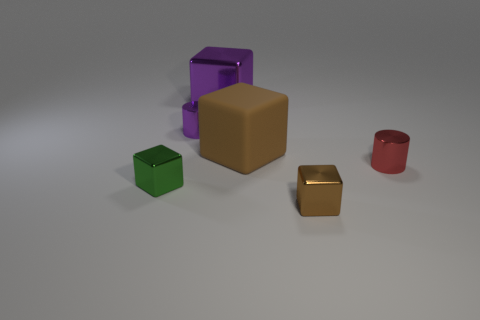Subtract all large brown blocks. How many blocks are left? 3 Subtract all purple blocks. How many blocks are left? 3 Add 3 tiny green rubber spheres. How many objects exist? 9 Subtract 3 cubes. How many cubes are left? 1 Add 6 brown metallic cubes. How many brown metallic cubes exist? 7 Subtract 0 blue balls. How many objects are left? 6 Subtract all cylinders. How many objects are left? 4 Subtract all blue cylinders. Subtract all gray spheres. How many cylinders are left? 2 Subtract all cyan spheres. How many yellow blocks are left? 0 Subtract all big gray shiny blocks. Subtract all large purple objects. How many objects are left? 5 